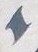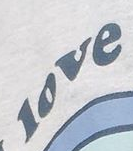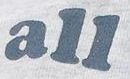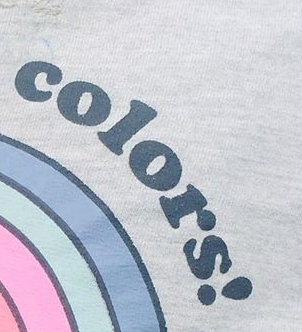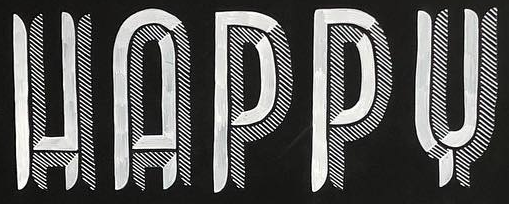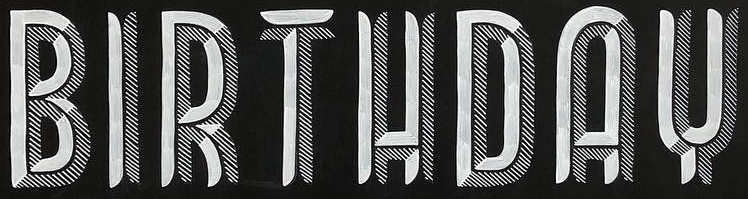Read the text content from these images in order, separated by a semicolon. I; love; all; colors!; HAPPY; BIRTHDAY 